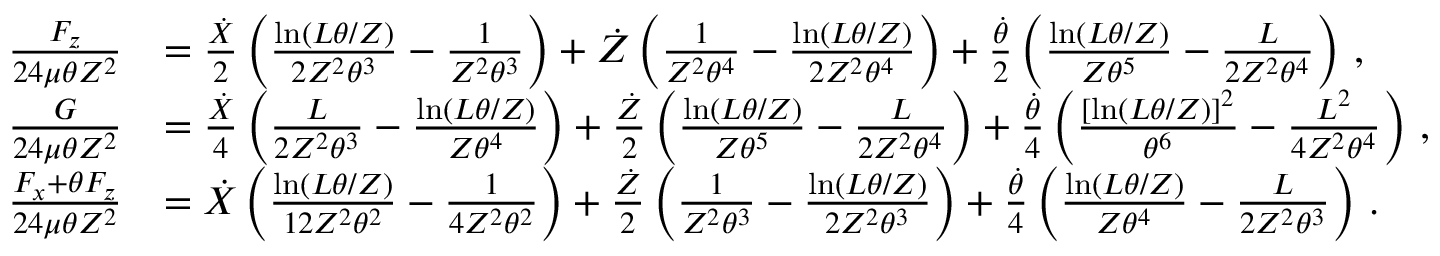<formula> <loc_0><loc_0><loc_500><loc_500>\begin{array} { r l } { \frac { F _ { z } } { 2 4 \mu \theta Z ^ { 2 } } } & { = \frac { \dot { X } } { 2 } \left ( \frac { \ln ( L \theta / Z ) } { 2 Z ^ { 2 } \theta ^ { 3 } } - \frac { 1 } { Z ^ { 2 } \theta ^ { 3 } } \right ) + \dot { Z } \left ( \frac { 1 } { Z ^ { 2 } \theta ^ { 4 } } - \frac { \ln ( L \theta / Z ) } { 2 Z ^ { 2 } \theta ^ { 4 } } \right ) + \frac { \dot { \theta } } { 2 } \left ( \frac { \ln ( L \theta / Z ) } { Z \theta ^ { 5 } } - \frac { L } { 2 Z ^ { 2 } \theta ^ { 4 } } \right ) \, , } \\ { \frac { G } { 2 4 \mu \theta Z ^ { 2 } } } & { = \frac { \dot { X } } { 4 } \left ( \frac { L } { 2 Z ^ { 2 } \theta ^ { 3 } } - \frac { \ln ( L \theta / Z ) } { Z \theta ^ { 4 } } \right ) + \frac { \dot { Z } } { 2 } \left ( \frac { \ln ( L \theta / Z ) } { Z \theta ^ { 5 } } - \frac { L } { 2 Z ^ { 2 } \theta ^ { 4 } } \right ) + \frac { \dot { \theta } } { 4 } \left ( \frac { [ \ln ( L \theta / Z ) ] ^ { 2 } } { \theta ^ { 6 } } - \frac { L ^ { 2 } } { 4 Z ^ { 2 } \theta ^ { 4 } } \right ) \, , } \\ { \frac { F _ { x } + \theta F _ { z } } { 2 4 \mu \theta Z ^ { 2 } } } & { = \dot { X } \left ( \frac { \ln ( L \theta / Z ) } { 1 2 Z ^ { 2 } \theta ^ { 2 } } - \frac { 1 } { 4 Z ^ { 2 } \theta ^ { 2 } } \right ) + \frac { \dot { Z } } { 2 } \left ( \frac { 1 } { Z ^ { 2 } \theta ^ { 3 } } - \frac { \ln ( L \theta / Z ) } { 2 Z ^ { 2 } \theta ^ { 3 } } \right ) + \frac { \dot { \theta } } { 4 } \left ( \frac { \ln ( L \theta / Z ) } { Z \theta ^ { 4 } } - \frac { L } { 2 Z ^ { 2 } \theta ^ { 3 } } \right ) \, . } \end{array}</formula> 